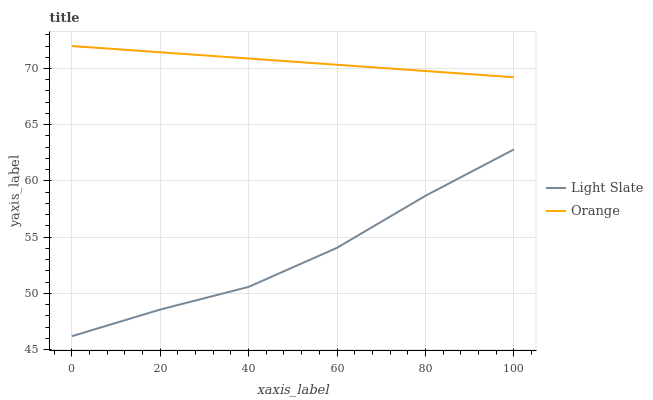Does Light Slate have the minimum area under the curve?
Answer yes or no. Yes. Does Orange have the maximum area under the curve?
Answer yes or no. Yes. Does Orange have the minimum area under the curve?
Answer yes or no. No. Is Orange the smoothest?
Answer yes or no. Yes. Is Light Slate the roughest?
Answer yes or no. Yes. Is Orange the roughest?
Answer yes or no. No. Does Orange have the lowest value?
Answer yes or no. No. Is Light Slate less than Orange?
Answer yes or no. Yes. Is Orange greater than Light Slate?
Answer yes or no. Yes. Does Light Slate intersect Orange?
Answer yes or no. No. 